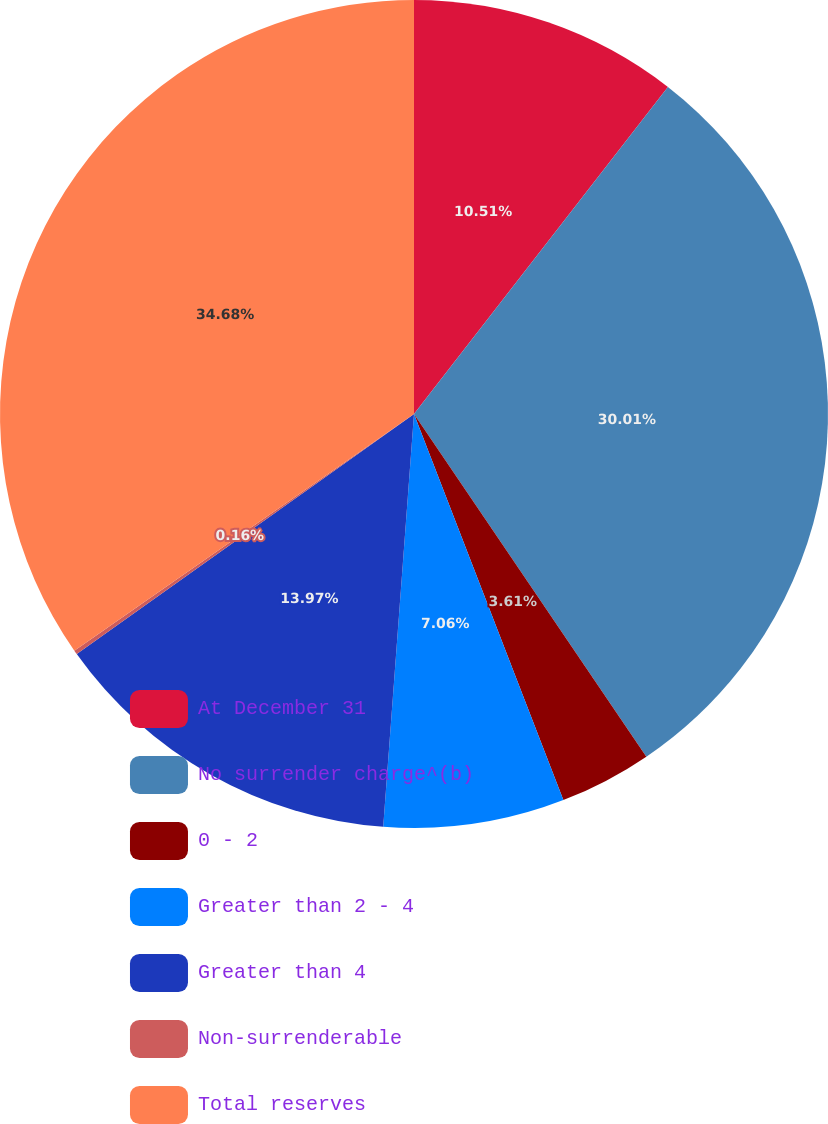<chart> <loc_0><loc_0><loc_500><loc_500><pie_chart><fcel>At December 31<fcel>No surrender charge^(b)<fcel>0 - 2<fcel>Greater than 2 - 4<fcel>Greater than 4<fcel>Non-surrenderable<fcel>Total reserves<nl><fcel>10.51%<fcel>30.01%<fcel>3.61%<fcel>7.06%<fcel>13.97%<fcel>0.16%<fcel>34.69%<nl></chart> 